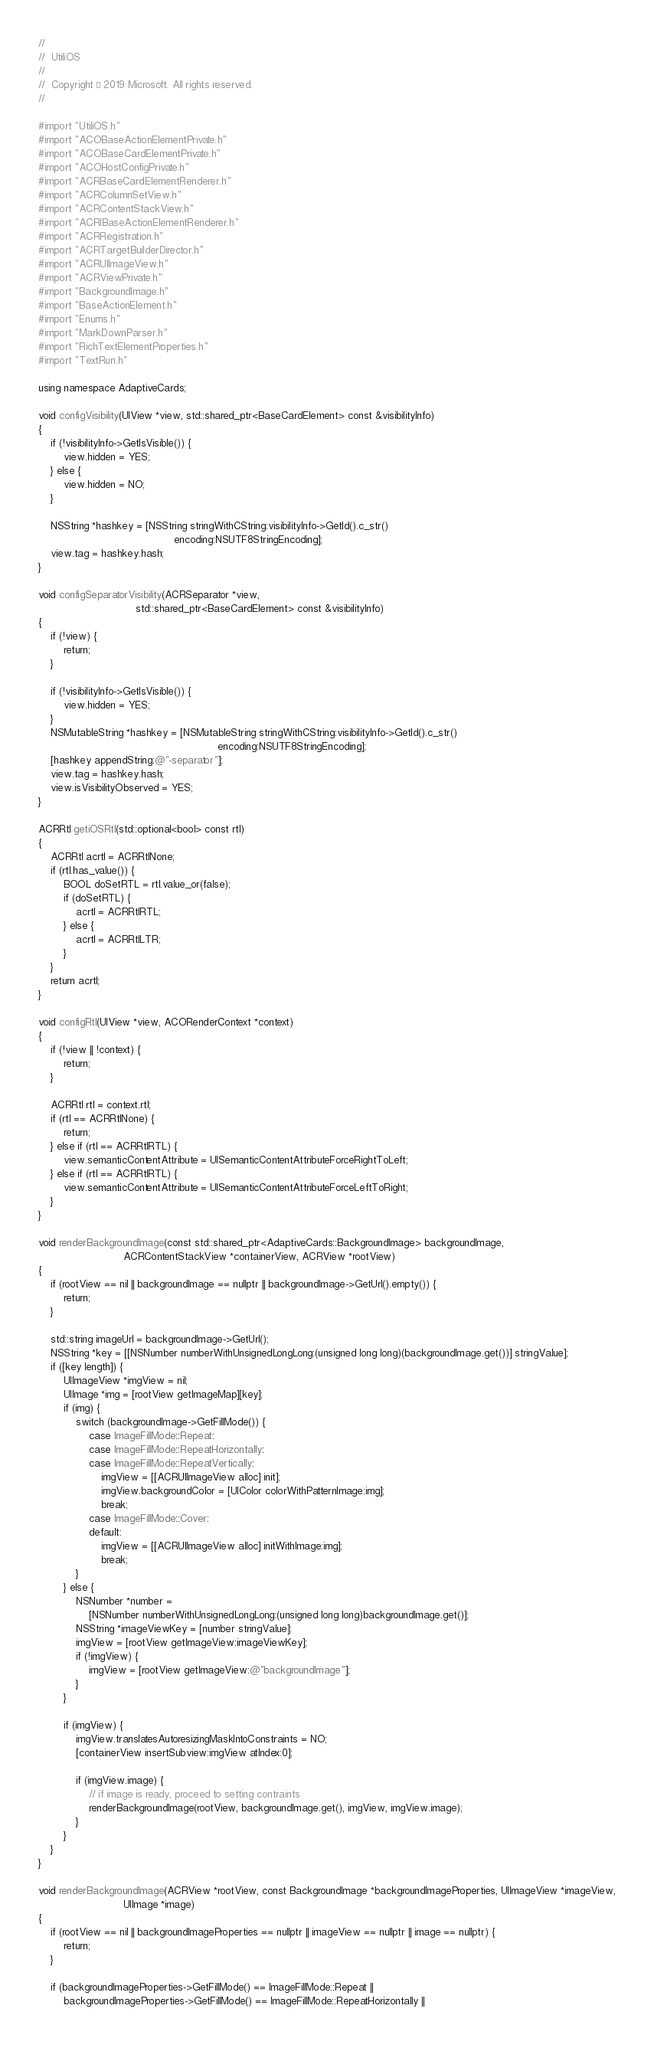<code> <loc_0><loc_0><loc_500><loc_500><_ObjectiveC_>//
//  UtiliOS
//
//  Copyright © 2019 Microsoft. All rights reserved.
//

#import "UtiliOS.h"
#import "ACOBaseActionElementPrivate.h"
#import "ACOBaseCardElementPrivate.h"
#import "ACOHostConfigPrivate.h"
#import "ACRBaseCardElementRenderer.h"
#import "ACRColumnSetView.h"
#import "ACRContentStackView.h"
#import "ACRIBaseActionElementRenderer.h"
#import "ACRRegistration.h"
#import "ACRTargetBuilderDirector.h"
#import "ACRUIImageView.h"
#import "ACRViewPrivate.h"
#import "BackgroundImage.h"
#import "BaseActionElement.h"
#import "Enums.h"
#import "MarkDownParser.h"
#import "RichTextElementProperties.h"
#import "TextRun.h"

using namespace AdaptiveCards;

void configVisibility(UIView *view, std::shared_ptr<BaseCardElement> const &visibilityInfo)
{
    if (!visibilityInfo->GetIsVisible()) {
        view.hidden = YES;
    } else {
        view.hidden = NO;
    }

    NSString *hashkey = [NSString stringWithCString:visibilityInfo->GetId().c_str()
                                           encoding:NSUTF8StringEncoding];
    view.tag = hashkey.hash;
}

void configSeparatorVisibility(ACRSeparator *view,
                               std::shared_ptr<BaseCardElement> const &visibilityInfo)
{
    if (!view) {
        return;
    }

    if (!visibilityInfo->GetIsVisible()) {
        view.hidden = YES;
    }
    NSMutableString *hashkey = [NSMutableString stringWithCString:visibilityInfo->GetId().c_str()
                                                         encoding:NSUTF8StringEncoding];
    [hashkey appendString:@"-separator"];
    view.tag = hashkey.hash;
    view.isVisibilityObserved = YES;
}

ACRRtl getiOSRtl(std::optional<bool> const rtl)
{
    ACRRtl acrtl = ACRRtlNone;
    if (rtl.has_value()) {
        BOOL doSetRTL = rtl.value_or(false);
        if (doSetRTL) {
            acrtl = ACRRtlRTL;
        } else {
            acrtl = ACRRtlLTR;
        }
    }
    return acrtl;
}

void configRtl(UIView *view, ACORenderContext *context)
{
    if (!view || !context) {
        return;
    }

    ACRRtl rtl = context.rtl;
    if (rtl == ACRRtlNone) {
        return;
    } else if (rtl == ACRRtlRTL) {
        view.semanticContentAttribute = UISemanticContentAttributeForceRightToLeft;
    } else if (rtl == ACRRtlRTL) {
        view.semanticContentAttribute = UISemanticContentAttributeForceLeftToRight;
    }
}

void renderBackgroundImage(const std::shared_ptr<AdaptiveCards::BackgroundImage> backgroundImage,
                           ACRContentStackView *containerView, ACRView *rootView)
{
    if (rootView == nil || backgroundImage == nullptr || backgroundImage->GetUrl().empty()) {
        return;
    }

    std::string imageUrl = backgroundImage->GetUrl();
    NSString *key = [[NSNumber numberWithUnsignedLongLong:(unsigned long long)(backgroundImage.get())] stringValue];
    if ([key length]) {
        UIImageView *imgView = nil;
        UIImage *img = [rootView getImageMap][key];
        if (img) {
            switch (backgroundImage->GetFillMode()) {
                case ImageFillMode::Repeat:
                case ImageFillMode::RepeatHorizontally:
                case ImageFillMode::RepeatVertically:
                    imgView = [[ACRUIImageView alloc] init];
                    imgView.backgroundColor = [UIColor colorWithPatternImage:img];
                    break;
                case ImageFillMode::Cover:
                default:
                    imgView = [[ACRUIImageView alloc] initWithImage:img];
                    break;
            }
        } else {
            NSNumber *number =
                [NSNumber numberWithUnsignedLongLong:(unsigned long long)backgroundImage.get()];
            NSString *imageViewKey = [number stringValue];
            imgView = [rootView getImageView:imageViewKey];
            if (!imgView) {
                imgView = [rootView getImageView:@"backgroundImage"];
            }
        }

        if (imgView) {
            imgView.translatesAutoresizingMaskIntoConstraints = NO;
            [containerView insertSubview:imgView atIndex:0];

            if (imgView.image) {
                // if image is ready, proceed to setting contraints
                renderBackgroundImage(rootView, backgroundImage.get(), imgView, imgView.image);
            }
        }
    }
}

void renderBackgroundImage(ACRView *rootView, const BackgroundImage *backgroundImageProperties, UIImageView *imageView,
                           UIImage *image)
{
    if (rootView == nil || backgroundImageProperties == nullptr || imageView == nullptr || image == nullptr) {
        return;
    }

    if (backgroundImageProperties->GetFillMode() == ImageFillMode::Repeat ||
        backgroundImageProperties->GetFillMode() == ImageFillMode::RepeatHorizontally ||</code> 